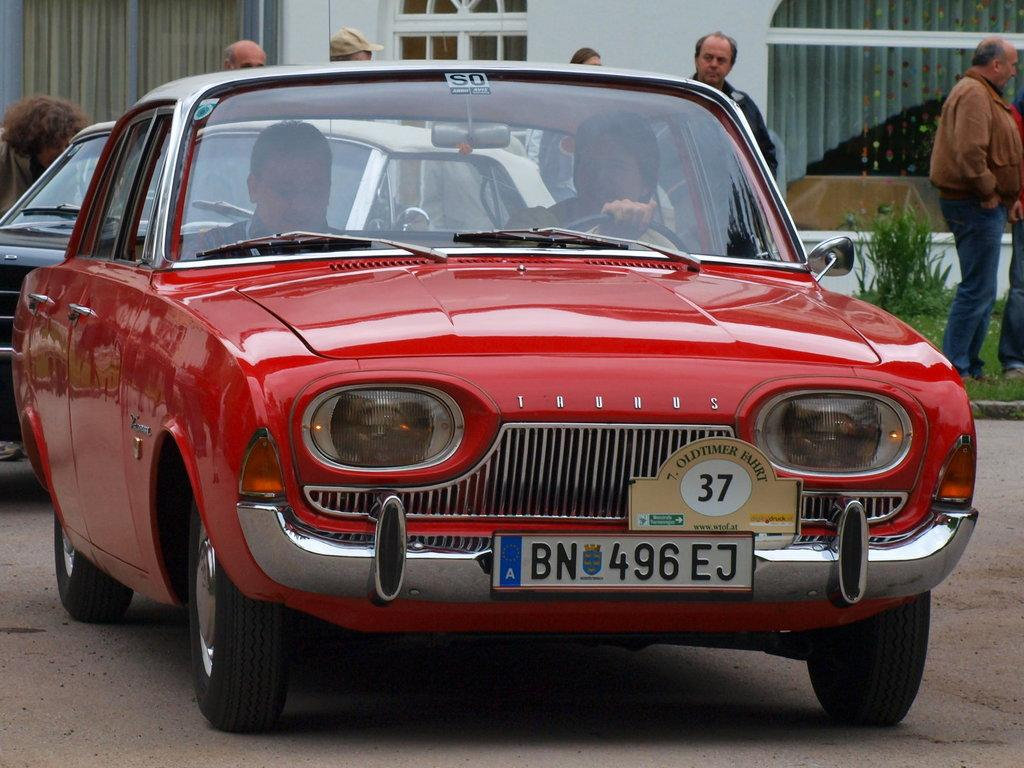What color is the car in the picture? The car in the picture is red. Who is inside the red car? Two persons are sitting inside the red car. Can you describe the people who are not in the car? There are people standing far away from the car. What can be seen in the background of the picture? There is a building with a window and curtains in the background. What type of vegetation is visible in the image? There are plants visible in the image. What type of chair is the squirrel sitting on in the image? There is no squirrel or chair present in the image. How many bears are visible in the image? There are no bears present in the image. 